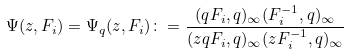<formula> <loc_0><loc_0><loc_500><loc_500>\Psi ( z , F _ { i } ) = \Psi _ { q } ( z , F _ { i } ) \colon = \frac { ( q F _ { i } , q ) _ { \infty } ( F _ { i } ^ { - 1 } , q ) _ { \infty } } { ( z q F _ { i } , q ) _ { \infty } ( z F _ { i } ^ { - 1 } , q ) _ { \infty } }</formula> 